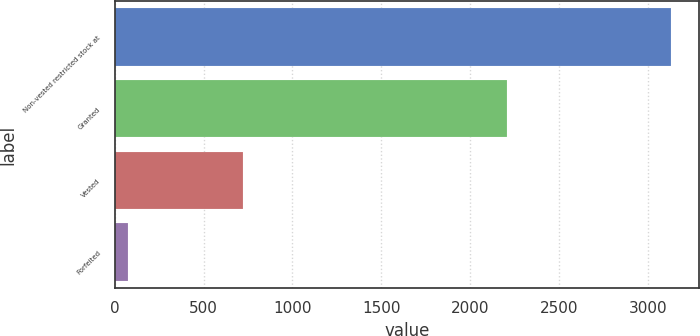Convert chart. <chart><loc_0><loc_0><loc_500><loc_500><bar_chart><fcel>Non-vested restricted stock at<fcel>Granted<fcel>Vested<fcel>Forfeited<nl><fcel>3131<fcel>2207<fcel>723<fcel>73<nl></chart> 